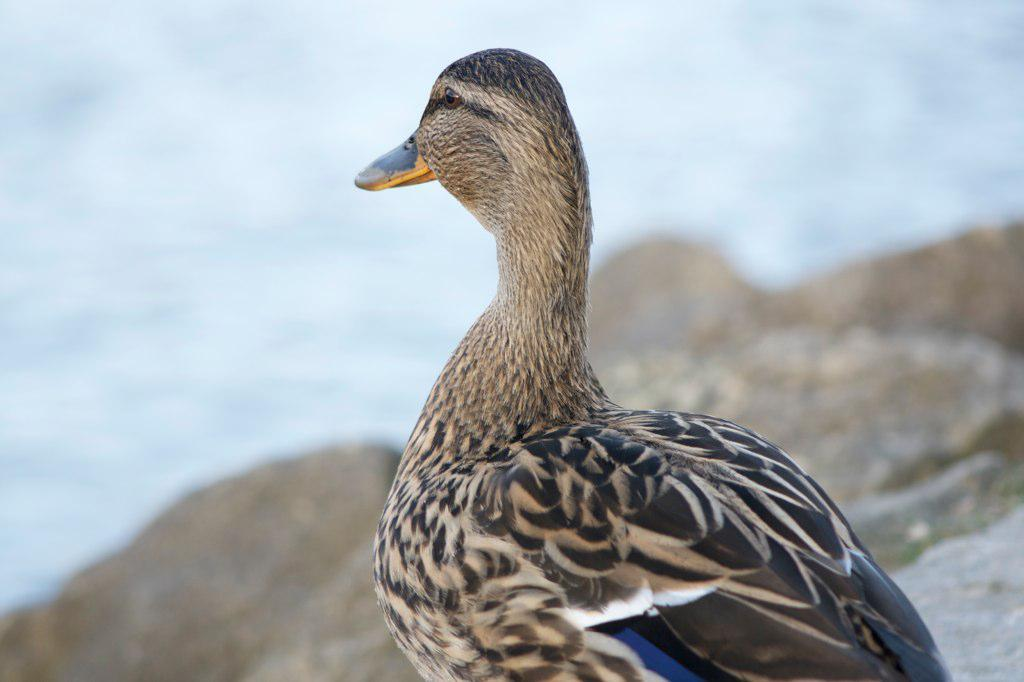What type of animal can be seen in the image? There is a bird in the image. Where is the bird located in the image? The bird is on the surface of something. What type of weather condition is depicted in the image? There is snow visible in the image. How many pizzas are being sold at the market in the image? There is no market or pizzas present in the image; it features a bird on a snowy surface. 